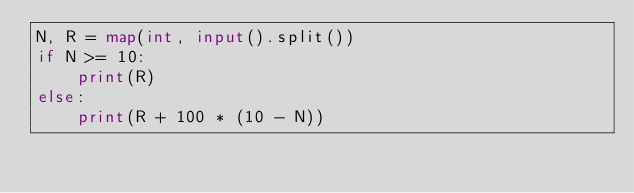<code> <loc_0><loc_0><loc_500><loc_500><_Python_>N, R = map(int, input().split())
if N >= 10:
    print(R)
else:
    print(R + 100 * (10 - N))</code> 